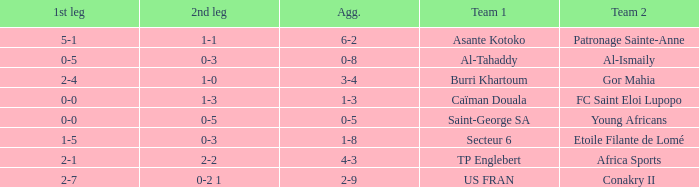Which team lost 0-3 and 0-5? Al-Tahaddy. 